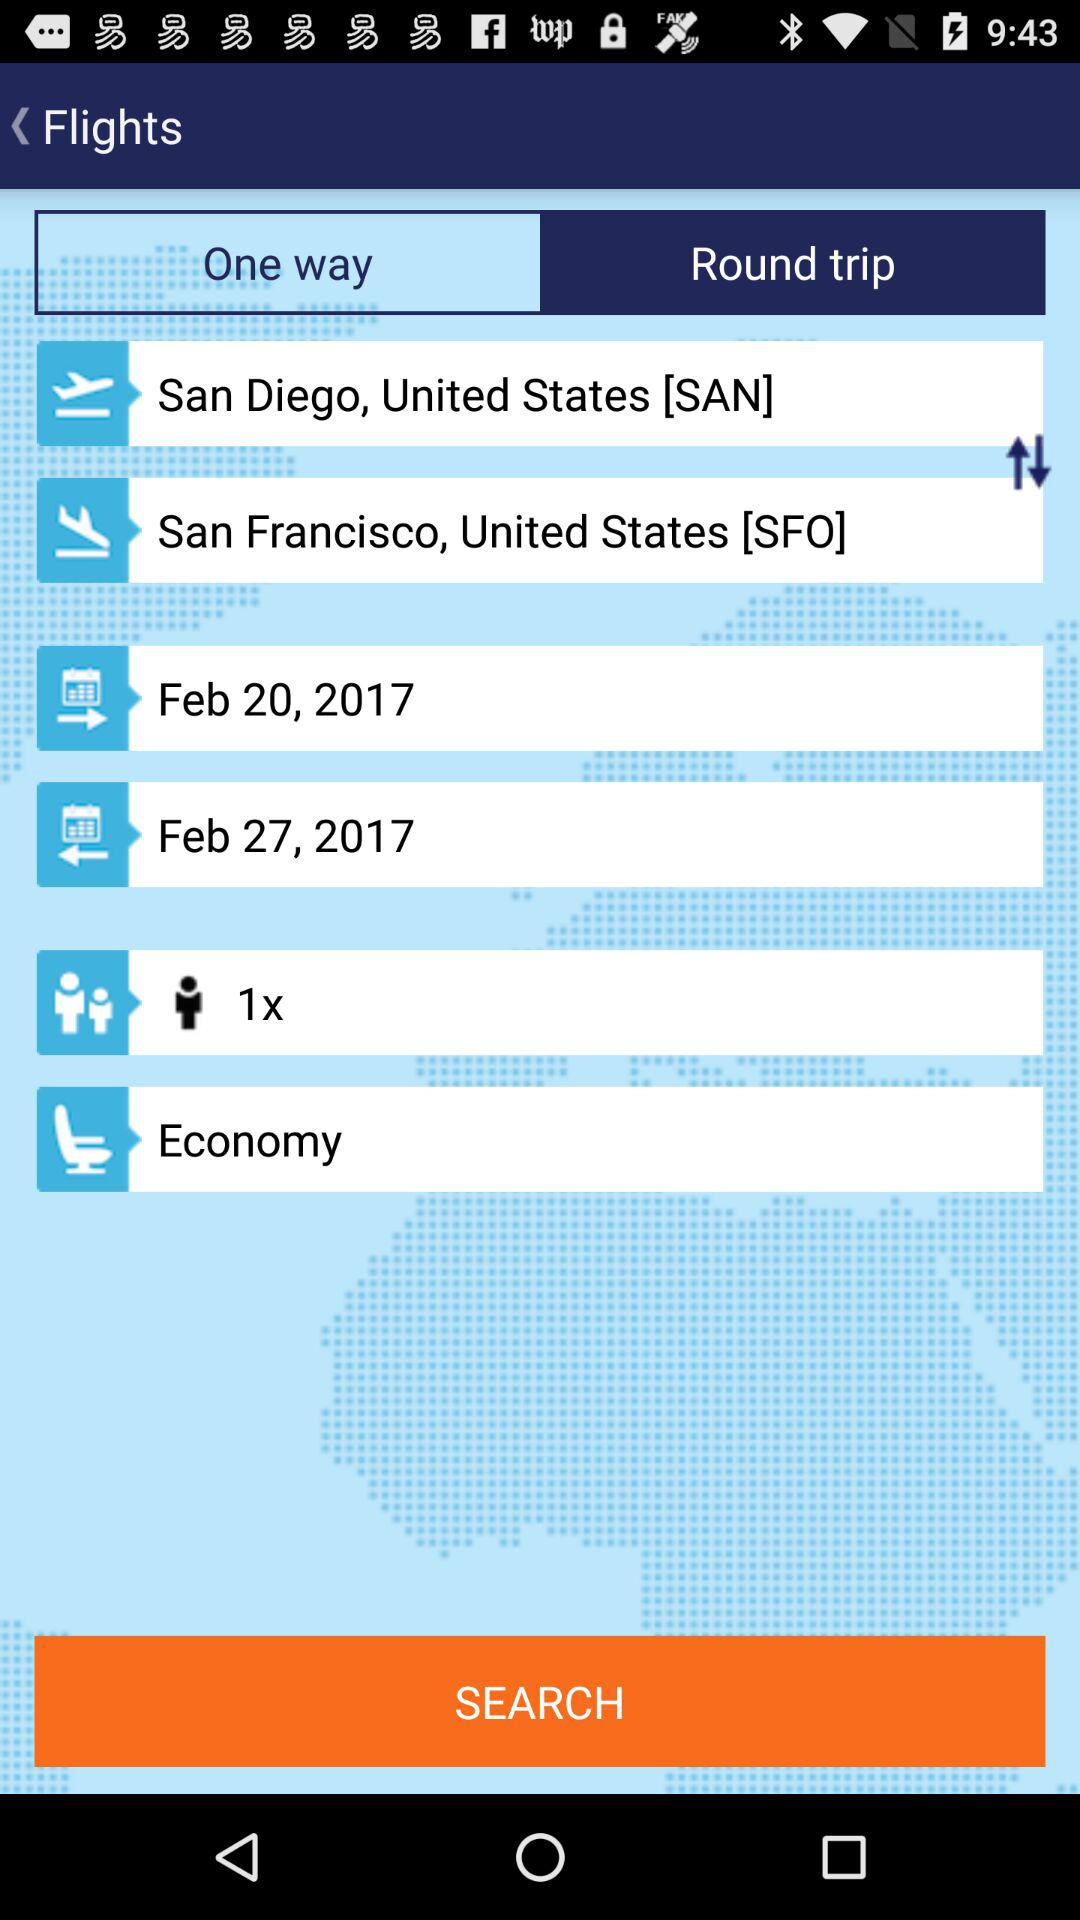What is the ending date of flight? The ending date is February 27, 2017. 